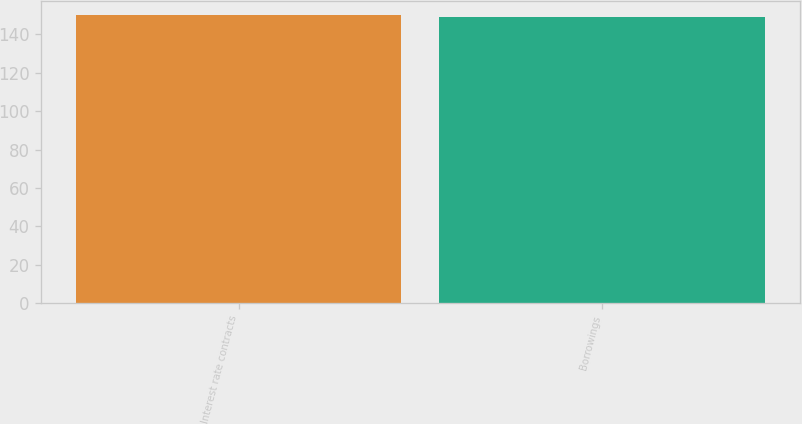Convert chart. <chart><loc_0><loc_0><loc_500><loc_500><bar_chart><fcel>Interest rate contracts<fcel>Borrowings<nl><fcel>150<fcel>149<nl></chart> 